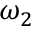Convert formula to latex. <formula><loc_0><loc_0><loc_500><loc_500>\omega _ { 2 }</formula> 